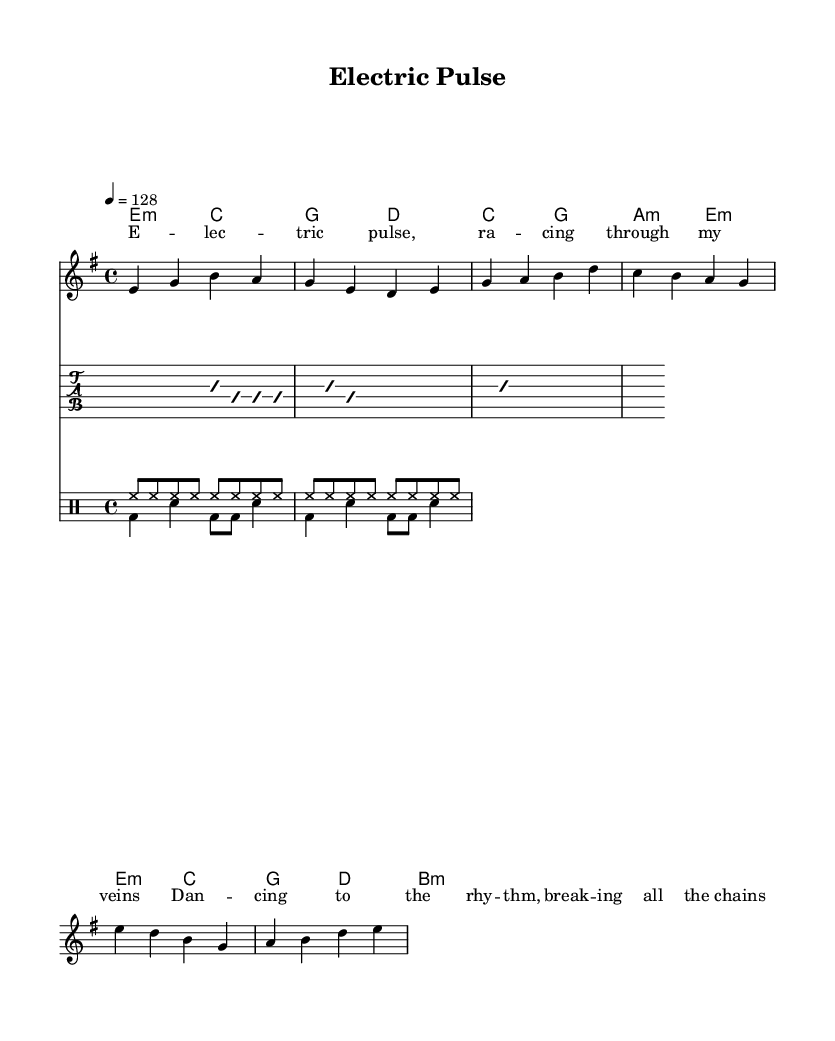What is the key signature of this music? The key signature is indicated at the beginning of the sheet music. It shows that there are no sharps or flats, which is characteristic of E minor.
Answer: E minor What is the time signature for this music? The time signature appears at the beginning of the sheet music. It indicates that there are four beats in each measure, which is represented by 4/4.
Answer: 4/4 What is the tempo marking? The tempo is marked as "4 = 128," meaning there are 128 beats per minute. This indicates how fast the piece should be played.
Answer: 128 How many measures are in the verse section? By examining the melody for the verse, there are two complete measures represented in the notation, showing where the verse section ends.
Answer: 2 What type of chords are used in the pre-chorus? The chords in the pre-chorus are represented in the chord mode section. They consist of a major chord and a minor chord: C major and A minor.
Answer: C major and A minor What kind of rhythm can you expect from the drums? The drumming part is indicated in two parts: the 'up' and 'down' rhythms. Analyzing those, the drumming incorporates a consistent hi-hat pattern and a kick-snare bass rhythm that keeps with the danceable beat.
Answer: Hi-hat and kick-snare rhythm What is the general theme expressed in the lyrics? The lyrics reflect a lively and energetic atmosphere, focusing on themes of dancing and the exhilaration of music, which is typical in modern alternative rock.
Answer: Dancing and exhilaration 